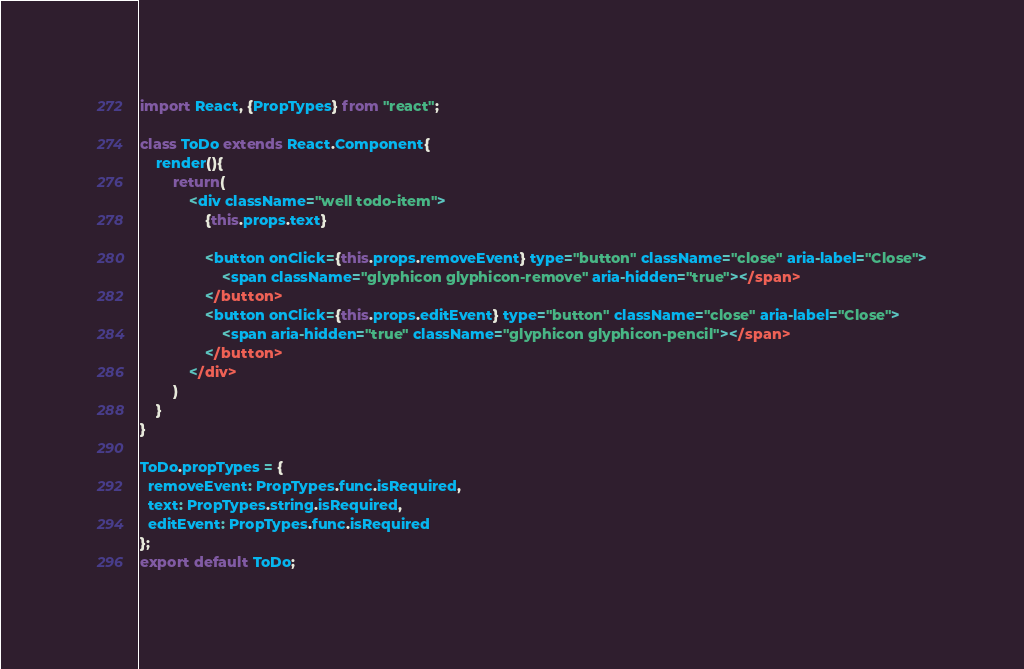<code> <loc_0><loc_0><loc_500><loc_500><_JavaScript_>import React, {PropTypes} from "react";

class ToDo extends React.Component{
    render(){
        return(
            <div className="well todo-item">
                {this.props.text}
        
                <button onClick={this.props.removeEvent} type="button" className="close" aria-label="Close">
                    <span className="glyphicon glyphicon-remove" aria-hidden="true"></span>
                </button>
                <button onClick={this.props.editEvent} type="button" className="close" aria-label="Close">
                    <span aria-hidden="true" className="glyphicon glyphicon-pencil"></span>
                </button>
            </div>
        )
    }
}

ToDo.propTypes = {
  removeEvent: PropTypes.func.isRequired,
  text: PropTypes.string.isRequired,
  editEvent: PropTypes.func.isRequired
};
export default ToDo;</code> 